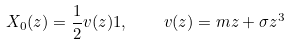<formula> <loc_0><loc_0><loc_500><loc_500>X _ { 0 } ( z ) = \frac { 1 } { 2 } v ( z ) 1 , \quad v ( z ) = m z + \sigma z ^ { 3 }</formula> 